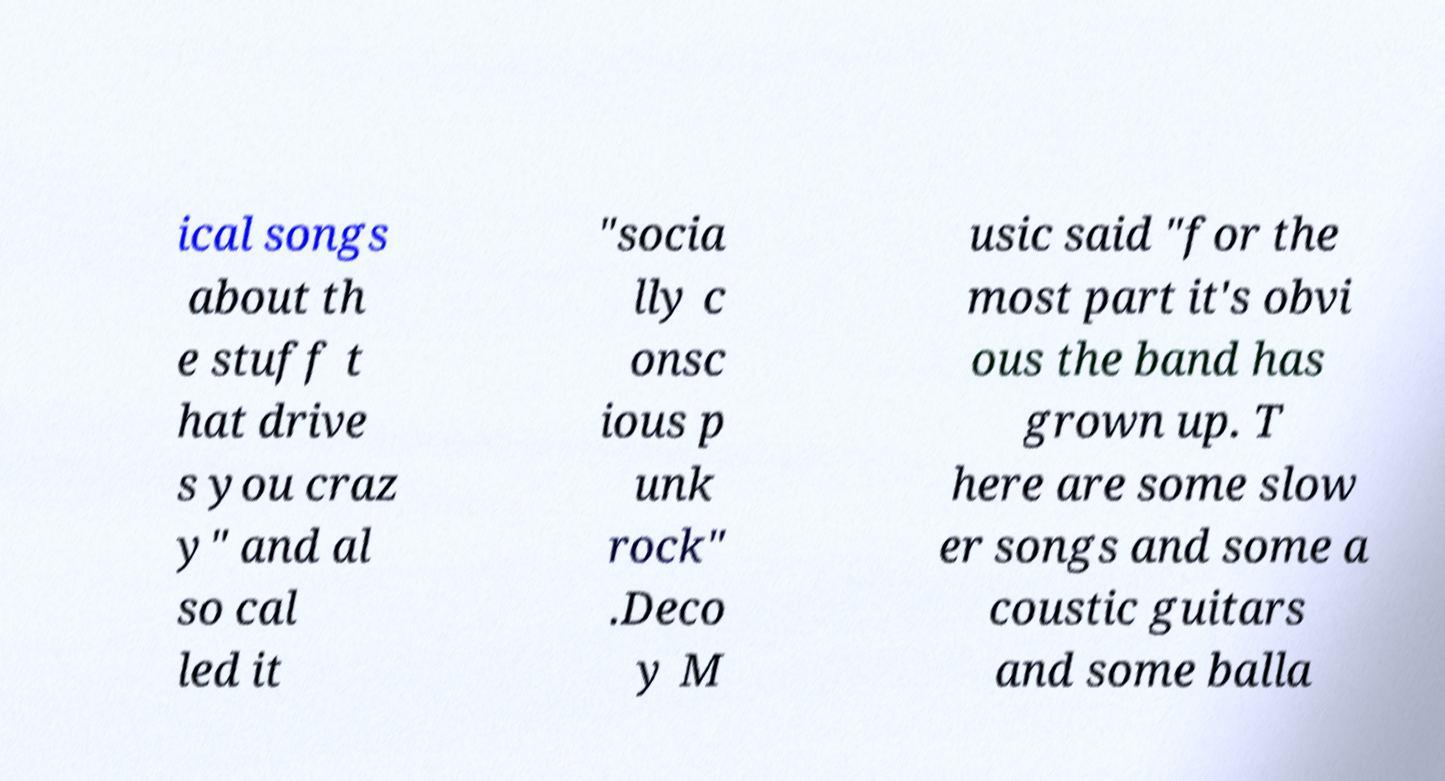Please identify and transcribe the text found in this image. ical songs about th e stuff t hat drive s you craz y" and al so cal led it "socia lly c onsc ious p unk rock" .Deco y M usic said "for the most part it's obvi ous the band has grown up. T here are some slow er songs and some a coustic guitars and some balla 